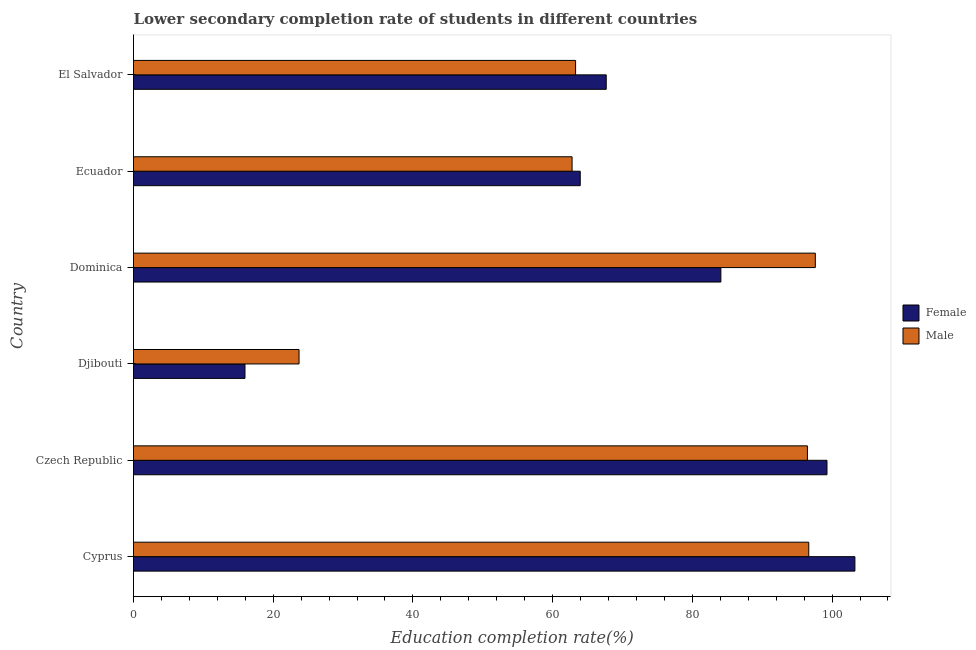How many different coloured bars are there?
Give a very brief answer. 2. Are the number of bars on each tick of the Y-axis equal?
Provide a short and direct response. Yes. How many bars are there on the 5th tick from the top?
Provide a succinct answer. 2. How many bars are there on the 6th tick from the bottom?
Provide a succinct answer. 2. What is the label of the 6th group of bars from the top?
Offer a very short reply. Cyprus. In how many cases, is the number of bars for a given country not equal to the number of legend labels?
Your answer should be very brief. 0. What is the education completion rate of male students in Czech Republic?
Ensure brevity in your answer.  96.47. Across all countries, what is the maximum education completion rate of male students?
Offer a very short reply. 97.6. Across all countries, what is the minimum education completion rate of female students?
Offer a terse response. 15.96. In which country was the education completion rate of male students maximum?
Your response must be concise. Dominica. In which country was the education completion rate of female students minimum?
Your response must be concise. Djibouti. What is the total education completion rate of male students in the graph?
Make the answer very short. 440.5. What is the difference between the education completion rate of male students in Cyprus and that in Ecuador?
Your answer should be very brief. 33.88. What is the difference between the education completion rate of female students in Czech Republic and the education completion rate of male students in Djibouti?
Your answer should be compact. 75.57. What is the average education completion rate of male students per country?
Your response must be concise. 73.42. What is the difference between the education completion rate of male students and education completion rate of female students in Djibouti?
Make the answer very short. 7.74. What is the ratio of the education completion rate of female students in Djibouti to that in Dominica?
Your response must be concise. 0.19. What is the difference between the highest and the second highest education completion rate of male students?
Offer a terse response. 0.94. What is the difference between the highest and the lowest education completion rate of male students?
Give a very brief answer. 73.91. In how many countries, is the education completion rate of female students greater than the average education completion rate of female students taken over all countries?
Your answer should be compact. 3. Are all the bars in the graph horizontal?
Ensure brevity in your answer.  Yes. How many countries are there in the graph?
Offer a very short reply. 6. Are the values on the major ticks of X-axis written in scientific E-notation?
Provide a succinct answer. No. Does the graph contain any zero values?
Offer a very short reply. No. Does the graph contain grids?
Your answer should be compact. No. What is the title of the graph?
Offer a terse response. Lower secondary completion rate of students in different countries. What is the label or title of the X-axis?
Your answer should be very brief. Education completion rate(%). What is the label or title of the Y-axis?
Your answer should be very brief. Country. What is the Education completion rate(%) in Female in Cyprus?
Your response must be concise. 103.27. What is the Education completion rate(%) in Male in Cyprus?
Keep it short and to the point. 96.66. What is the Education completion rate(%) of Female in Czech Republic?
Keep it short and to the point. 99.27. What is the Education completion rate(%) in Male in Czech Republic?
Offer a very short reply. 96.47. What is the Education completion rate(%) of Female in Djibouti?
Your answer should be very brief. 15.96. What is the Education completion rate(%) of Male in Djibouti?
Offer a terse response. 23.7. What is the Education completion rate(%) in Female in Dominica?
Keep it short and to the point. 84.08. What is the Education completion rate(%) of Male in Dominica?
Provide a succinct answer. 97.6. What is the Education completion rate(%) in Female in Ecuador?
Keep it short and to the point. 63.95. What is the Education completion rate(%) in Male in Ecuador?
Your response must be concise. 62.78. What is the Education completion rate(%) in Female in El Salvador?
Make the answer very short. 67.67. What is the Education completion rate(%) in Male in El Salvador?
Offer a very short reply. 63.29. Across all countries, what is the maximum Education completion rate(%) in Female?
Ensure brevity in your answer.  103.27. Across all countries, what is the maximum Education completion rate(%) in Male?
Give a very brief answer. 97.6. Across all countries, what is the minimum Education completion rate(%) in Female?
Your answer should be very brief. 15.96. Across all countries, what is the minimum Education completion rate(%) of Male?
Your response must be concise. 23.7. What is the total Education completion rate(%) of Female in the graph?
Offer a terse response. 434.2. What is the total Education completion rate(%) in Male in the graph?
Provide a succinct answer. 440.5. What is the difference between the Education completion rate(%) in Female in Cyprus and that in Czech Republic?
Your answer should be very brief. 4. What is the difference between the Education completion rate(%) in Male in Cyprus and that in Czech Republic?
Ensure brevity in your answer.  0.19. What is the difference between the Education completion rate(%) of Female in Cyprus and that in Djibouti?
Provide a short and direct response. 87.31. What is the difference between the Education completion rate(%) of Male in Cyprus and that in Djibouti?
Your answer should be very brief. 72.97. What is the difference between the Education completion rate(%) in Female in Cyprus and that in Dominica?
Give a very brief answer. 19.19. What is the difference between the Education completion rate(%) in Male in Cyprus and that in Dominica?
Provide a short and direct response. -0.94. What is the difference between the Education completion rate(%) of Female in Cyprus and that in Ecuador?
Provide a short and direct response. 39.32. What is the difference between the Education completion rate(%) of Male in Cyprus and that in Ecuador?
Keep it short and to the point. 33.88. What is the difference between the Education completion rate(%) in Female in Cyprus and that in El Salvador?
Keep it short and to the point. 35.6. What is the difference between the Education completion rate(%) in Male in Cyprus and that in El Salvador?
Provide a succinct answer. 33.38. What is the difference between the Education completion rate(%) in Female in Czech Republic and that in Djibouti?
Provide a succinct answer. 83.31. What is the difference between the Education completion rate(%) of Male in Czech Republic and that in Djibouti?
Provide a succinct answer. 72.77. What is the difference between the Education completion rate(%) in Female in Czech Republic and that in Dominica?
Make the answer very short. 15.19. What is the difference between the Education completion rate(%) in Male in Czech Republic and that in Dominica?
Offer a very short reply. -1.13. What is the difference between the Education completion rate(%) in Female in Czech Republic and that in Ecuador?
Make the answer very short. 35.32. What is the difference between the Education completion rate(%) of Male in Czech Republic and that in Ecuador?
Offer a very short reply. 33.69. What is the difference between the Education completion rate(%) of Female in Czech Republic and that in El Salvador?
Ensure brevity in your answer.  31.6. What is the difference between the Education completion rate(%) in Male in Czech Republic and that in El Salvador?
Offer a terse response. 33.18. What is the difference between the Education completion rate(%) in Female in Djibouti and that in Dominica?
Keep it short and to the point. -68.12. What is the difference between the Education completion rate(%) of Male in Djibouti and that in Dominica?
Ensure brevity in your answer.  -73.91. What is the difference between the Education completion rate(%) of Female in Djibouti and that in Ecuador?
Provide a succinct answer. -47.99. What is the difference between the Education completion rate(%) of Male in Djibouti and that in Ecuador?
Your response must be concise. -39.08. What is the difference between the Education completion rate(%) in Female in Djibouti and that in El Salvador?
Provide a short and direct response. -51.71. What is the difference between the Education completion rate(%) of Male in Djibouti and that in El Salvador?
Offer a terse response. -39.59. What is the difference between the Education completion rate(%) of Female in Dominica and that in Ecuador?
Your answer should be very brief. 20.13. What is the difference between the Education completion rate(%) in Male in Dominica and that in Ecuador?
Your response must be concise. 34.82. What is the difference between the Education completion rate(%) of Female in Dominica and that in El Salvador?
Your answer should be very brief. 16.41. What is the difference between the Education completion rate(%) of Male in Dominica and that in El Salvador?
Offer a very short reply. 34.32. What is the difference between the Education completion rate(%) in Female in Ecuador and that in El Salvador?
Your response must be concise. -3.72. What is the difference between the Education completion rate(%) in Male in Ecuador and that in El Salvador?
Provide a succinct answer. -0.5. What is the difference between the Education completion rate(%) of Female in Cyprus and the Education completion rate(%) of Male in Czech Republic?
Your response must be concise. 6.8. What is the difference between the Education completion rate(%) in Female in Cyprus and the Education completion rate(%) in Male in Djibouti?
Provide a succinct answer. 79.57. What is the difference between the Education completion rate(%) in Female in Cyprus and the Education completion rate(%) in Male in Dominica?
Your answer should be very brief. 5.67. What is the difference between the Education completion rate(%) in Female in Cyprus and the Education completion rate(%) in Male in Ecuador?
Your answer should be compact. 40.49. What is the difference between the Education completion rate(%) of Female in Cyprus and the Education completion rate(%) of Male in El Salvador?
Ensure brevity in your answer.  39.98. What is the difference between the Education completion rate(%) in Female in Czech Republic and the Education completion rate(%) in Male in Djibouti?
Your answer should be compact. 75.57. What is the difference between the Education completion rate(%) in Female in Czech Republic and the Education completion rate(%) in Male in Dominica?
Give a very brief answer. 1.67. What is the difference between the Education completion rate(%) in Female in Czech Republic and the Education completion rate(%) in Male in Ecuador?
Give a very brief answer. 36.49. What is the difference between the Education completion rate(%) in Female in Czech Republic and the Education completion rate(%) in Male in El Salvador?
Offer a very short reply. 35.99. What is the difference between the Education completion rate(%) in Female in Djibouti and the Education completion rate(%) in Male in Dominica?
Provide a succinct answer. -81.65. What is the difference between the Education completion rate(%) in Female in Djibouti and the Education completion rate(%) in Male in Ecuador?
Provide a succinct answer. -46.82. What is the difference between the Education completion rate(%) of Female in Djibouti and the Education completion rate(%) of Male in El Salvador?
Provide a short and direct response. -47.33. What is the difference between the Education completion rate(%) in Female in Dominica and the Education completion rate(%) in Male in Ecuador?
Your answer should be compact. 21.3. What is the difference between the Education completion rate(%) in Female in Dominica and the Education completion rate(%) in Male in El Salvador?
Keep it short and to the point. 20.8. What is the difference between the Education completion rate(%) of Female in Ecuador and the Education completion rate(%) of Male in El Salvador?
Keep it short and to the point. 0.66. What is the average Education completion rate(%) in Female per country?
Your answer should be very brief. 72.37. What is the average Education completion rate(%) of Male per country?
Offer a terse response. 73.42. What is the difference between the Education completion rate(%) in Female and Education completion rate(%) in Male in Cyprus?
Provide a short and direct response. 6.61. What is the difference between the Education completion rate(%) of Female and Education completion rate(%) of Male in Czech Republic?
Your answer should be very brief. 2.8. What is the difference between the Education completion rate(%) in Female and Education completion rate(%) in Male in Djibouti?
Keep it short and to the point. -7.74. What is the difference between the Education completion rate(%) of Female and Education completion rate(%) of Male in Dominica?
Your answer should be compact. -13.52. What is the difference between the Education completion rate(%) in Female and Education completion rate(%) in Male in Ecuador?
Offer a very short reply. 1.17. What is the difference between the Education completion rate(%) in Female and Education completion rate(%) in Male in El Salvador?
Your answer should be compact. 4.39. What is the ratio of the Education completion rate(%) of Female in Cyprus to that in Czech Republic?
Provide a succinct answer. 1.04. What is the ratio of the Education completion rate(%) in Male in Cyprus to that in Czech Republic?
Offer a very short reply. 1. What is the ratio of the Education completion rate(%) of Female in Cyprus to that in Djibouti?
Your answer should be very brief. 6.47. What is the ratio of the Education completion rate(%) in Male in Cyprus to that in Djibouti?
Ensure brevity in your answer.  4.08. What is the ratio of the Education completion rate(%) in Female in Cyprus to that in Dominica?
Keep it short and to the point. 1.23. What is the ratio of the Education completion rate(%) of Female in Cyprus to that in Ecuador?
Ensure brevity in your answer.  1.61. What is the ratio of the Education completion rate(%) in Male in Cyprus to that in Ecuador?
Offer a terse response. 1.54. What is the ratio of the Education completion rate(%) of Female in Cyprus to that in El Salvador?
Make the answer very short. 1.53. What is the ratio of the Education completion rate(%) in Male in Cyprus to that in El Salvador?
Offer a very short reply. 1.53. What is the ratio of the Education completion rate(%) in Female in Czech Republic to that in Djibouti?
Make the answer very short. 6.22. What is the ratio of the Education completion rate(%) in Male in Czech Republic to that in Djibouti?
Provide a short and direct response. 4.07. What is the ratio of the Education completion rate(%) in Female in Czech Republic to that in Dominica?
Your answer should be compact. 1.18. What is the ratio of the Education completion rate(%) in Male in Czech Republic to that in Dominica?
Offer a very short reply. 0.99. What is the ratio of the Education completion rate(%) of Female in Czech Republic to that in Ecuador?
Offer a very short reply. 1.55. What is the ratio of the Education completion rate(%) of Male in Czech Republic to that in Ecuador?
Offer a very short reply. 1.54. What is the ratio of the Education completion rate(%) of Female in Czech Republic to that in El Salvador?
Ensure brevity in your answer.  1.47. What is the ratio of the Education completion rate(%) of Male in Czech Republic to that in El Salvador?
Ensure brevity in your answer.  1.52. What is the ratio of the Education completion rate(%) in Female in Djibouti to that in Dominica?
Ensure brevity in your answer.  0.19. What is the ratio of the Education completion rate(%) of Male in Djibouti to that in Dominica?
Provide a succinct answer. 0.24. What is the ratio of the Education completion rate(%) of Female in Djibouti to that in Ecuador?
Your answer should be very brief. 0.25. What is the ratio of the Education completion rate(%) of Male in Djibouti to that in Ecuador?
Provide a succinct answer. 0.38. What is the ratio of the Education completion rate(%) of Female in Djibouti to that in El Salvador?
Make the answer very short. 0.24. What is the ratio of the Education completion rate(%) in Male in Djibouti to that in El Salvador?
Provide a short and direct response. 0.37. What is the ratio of the Education completion rate(%) in Female in Dominica to that in Ecuador?
Your answer should be compact. 1.31. What is the ratio of the Education completion rate(%) in Male in Dominica to that in Ecuador?
Offer a terse response. 1.55. What is the ratio of the Education completion rate(%) in Female in Dominica to that in El Salvador?
Your answer should be very brief. 1.24. What is the ratio of the Education completion rate(%) in Male in Dominica to that in El Salvador?
Your answer should be compact. 1.54. What is the ratio of the Education completion rate(%) in Female in Ecuador to that in El Salvador?
Provide a short and direct response. 0.94. What is the difference between the highest and the second highest Education completion rate(%) in Female?
Your response must be concise. 4. What is the difference between the highest and the second highest Education completion rate(%) of Male?
Your response must be concise. 0.94. What is the difference between the highest and the lowest Education completion rate(%) of Female?
Provide a short and direct response. 87.31. What is the difference between the highest and the lowest Education completion rate(%) of Male?
Your response must be concise. 73.91. 